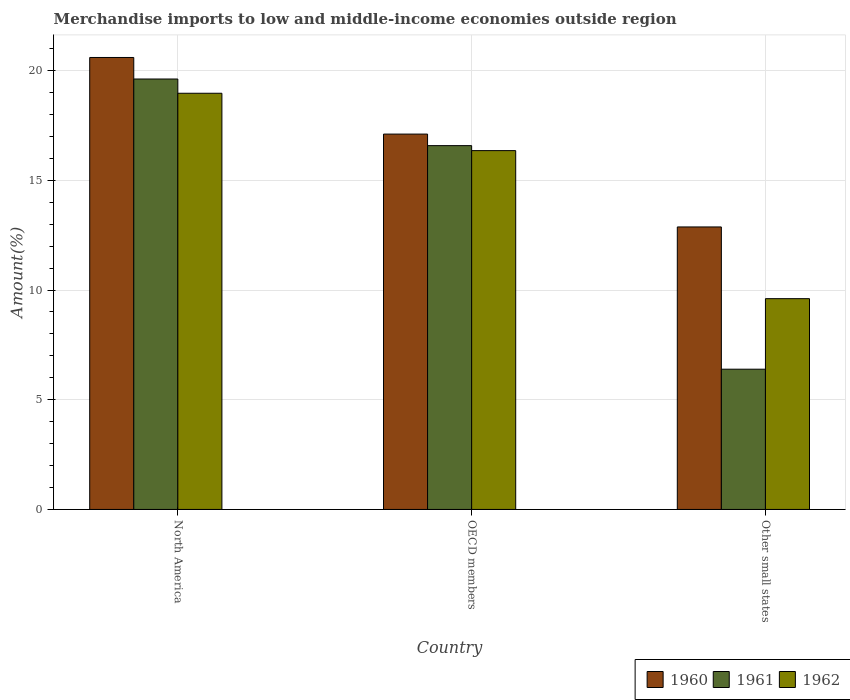How many different coloured bars are there?
Your answer should be compact. 3. How many groups of bars are there?
Your answer should be compact. 3. Are the number of bars on each tick of the X-axis equal?
Provide a short and direct response. Yes. How many bars are there on the 1st tick from the left?
Provide a short and direct response. 3. How many bars are there on the 3rd tick from the right?
Offer a terse response. 3. What is the label of the 1st group of bars from the left?
Provide a succinct answer. North America. What is the percentage of amount earned from merchandise imports in 1962 in OECD members?
Offer a terse response. 16.35. Across all countries, what is the maximum percentage of amount earned from merchandise imports in 1962?
Make the answer very short. 18.97. Across all countries, what is the minimum percentage of amount earned from merchandise imports in 1962?
Give a very brief answer. 9.61. In which country was the percentage of amount earned from merchandise imports in 1962 maximum?
Your answer should be very brief. North America. In which country was the percentage of amount earned from merchandise imports in 1962 minimum?
Offer a very short reply. Other small states. What is the total percentage of amount earned from merchandise imports in 1960 in the graph?
Provide a short and direct response. 50.58. What is the difference between the percentage of amount earned from merchandise imports in 1960 in North America and that in Other small states?
Offer a very short reply. 7.72. What is the difference between the percentage of amount earned from merchandise imports in 1961 in North America and the percentage of amount earned from merchandise imports in 1962 in Other small states?
Offer a very short reply. 10.01. What is the average percentage of amount earned from merchandise imports in 1962 per country?
Your response must be concise. 14.97. What is the difference between the percentage of amount earned from merchandise imports of/in 1960 and percentage of amount earned from merchandise imports of/in 1961 in North America?
Provide a short and direct response. 0.98. In how many countries, is the percentage of amount earned from merchandise imports in 1960 greater than 2 %?
Give a very brief answer. 3. What is the ratio of the percentage of amount earned from merchandise imports in 1962 in North America to that in Other small states?
Offer a very short reply. 1.97. What is the difference between the highest and the second highest percentage of amount earned from merchandise imports in 1960?
Offer a very short reply. -3.49. What is the difference between the highest and the lowest percentage of amount earned from merchandise imports in 1961?
Provide a succinct answer. 13.22. In how many countries, is the percentage of amount earned from merchandise imports in 1960 greater than the average percentage of amount earned from merchandise imports in 1960 taken over all countries?
Offer a very short reply. 2. Is the sum of the percentage of amount earned from merchandise imports in 1961 in OECD members and Other small states greater than the maximum percentage of amount earned from merchandise imports in 1962 across all countries?
Your answer should be compact. Yes. What does the 2nd bar from the right in North America represents?
Your response must be concise. 1961. How many bars are there?
Provide a succinct answer. 9. Are all the bars in the graph horizontal?
Offer a terse response. No. What is the difference between two consecutive major ticks on the Y-axis?
Your answer should be very brief. 5. Are the values on the major ticks of Y-axis written in scientific E-notation?
Offer a very short reply. No. Where does the legend appear in the graph?
Keep it short and to the point. Bottom right. What is the title of the graph?
Your answer should be very brief. Merchandise imports to low and middle-income economies outside region. Does "1963" appear as one of the legend labels in the graph?
Make the answer very short. No. What is the label or title of the X-axis?
Your answer should be compact. Country. What is the label or title of the Y-axis?
Make the answer very short. Amount(%). What is the Amount(%) in 1960 in North America?
Provide a short and direct response. 20.6. What is the Amount(%) of 1961 in North America?
Provide a short and direct response. 19.62. What is the Amount(%) in 1962 in North America?
Keep it short and to the point. 18.97. What is the Amount(%) of 1960 in OECD members?
Give a very brief answer. 17.11. What is the Amount(%) of 1961 in OECD members?
Provide a succinct answer. 16.58. What is the Amount(%) of 1962 in OECD members?
Offer a very short reply. 16.35. What is the Amount(%) in 1960 in Other small states?
Offer a very short reply. 12.87. What is the Amount(%) in 1961 in Other small states?
Offer a very short reply. 6.39. What is the Amount(%) of 1962 in Other small states?
Keep it short and to the point. 9.61. Across all countries, what is the maximum Amount(%) in 1960?
Keep it short and to the point. 20.6. Across all countries, what is the maximum Amount(%) in 1961?
Provide a succinct answer. 19.62. Across all countries, what is the maximum Amount(%) of 1962?
Provide a succinct answer. 18.97. Across all countries, what is the minimum Amount(%) in 1960?
Ensure brevity in your answer.  12.87. Across all countries, what is the minimum Amount(%) of 1961?
Offer a terse response. 6.39. Across all countries, what is the minimum Amount(%) in 1962?
Provide a succinct answer. 9.61. What is the total Amount(%) of 1960 in the graph?
Provide a short and direct response. 50.58. What is the total Amount(%) in 1961 in the graph?
Your answer should be compact. 42.59. What is the total Amount(%) of 1962 in the graph?
Keep it short and to the point. 44.92. What is the difference between the Amount(%) of 1960 in North America and that in OECD members?
Make the answer very short. 3.49. What is the difference between the Amount(%) of 1961 in North America and that in OECD members?
Ensure brevity in your answer.  3.04. What is the difference between the Amount(%) of 1962 in North America and that in OECD members?
Provide a succinct answer. 2.61. What is the difference between the Amount(%) in 1960 in North America and that in Other small states?
Provide a short and direct response. 7.72. What is the difference between the Amount(%) in 1961 in North America and that in Other small states?
Make the answer very short. 13.22. What is the difference between the Amount(%) in 1962 in North America and that in Other small states?
Ensure brevity in your answer.  9.36. What is the difference between the Amount(%) of 1960 in OECD members and that in Other small states?
Offer a terse response. 4.23. What is the difference between the Amount(%) in 1961 in OECD members and that in Other small states?
Your response must be concise. 10.19. What is the difference between the Amount(%) in 1962 in OECD members and that in Other small states?
Keep it short and to the point. 6.75. What is the difference between the Amount(%) in 1960 in North America and the Amount(%) in 1961 in OECD members?
Provide a short and direct response. 4.02. What is the difference between the Amount(%) of 1960 in North America and the Amount(%) of 1962 in OECD members?
Make the answer very short. 4.24. What is the difference between the Amount(%) of 1961 in North America and the Amount(%) of 1962 in OECD members?
Your answer should be very brief. 3.26. What is the difference between the Amount(%) of 1960 in North America and the Amount(%) of 1961 in Other small states?
Your answer should be compact. 14.21. What is the difference between the Amount(%) of 1960 in North America and the Amount(%) of 1962 in Other small states?
Make the answer very short. 10.99. What is the difference between the Amount(%) in 1961 in North America and the Amount(%) in 1962 in Other small states?
Give a very brief answer. 10.01. What is the difference between the Amount(%) of 1960 in OECD members and the Amount(%) of 1961 in Other small states?
Your answer should be very brief. 10.71. What is the difference between the Amount(%) of 1960 in OECD members and the Amount(%) of 1962 in Other small states?
Provide a succinct answer. 7.5. What is the difference between the Amount(%) of 1961 in OECD members and the Amount(%) of 1962 in Other small states?
Provide a succinct answer. 6.97. What is the average Amount(%) in 1960 per country?
Keep it short and to the point. 16.86. What is the average Amount(%) in 1961 per country?
Provide a succinct answer. 14.2. What is the average Amount(%) in 1962 per country?
Ensure brevity in your answer.  14.97. What is the difference between the Amount(%) in 1960 and Amount(%) in 1961 in North America?
Your response must be concise. 0.98. What is the difference between the Amount(%) of 1960 and Amount(%) of 1962 in North America?
Make the answer very short. 1.63. What is the difference between the Amount(%) of 1961 and Amount(%) of 1962 in North America?
Your response must be concise. 0.65. What is the difference between the Amount(%) in 1960 and Amount(%) in 1961 in OECD members?
Make the answer very short. 0.53. What is the difference between the Amount(%) of 1960 and Amount(%) of 1962 in OECD members?
Offer a terse response. 0.75. What is the difference between the Amount(%) of 1961 and Amount(%) of 1962 in OECD members?
Your response must be concise. 0.23. What is the difference between the Amount(%) of 1960 and Amount(%) of 1961 in Other small states?
Offer a terse response. 6.48. What is the difference between the Amount(%) in 1960 and Amount(%) in 1962 in Other small states?
Provide a succinct answer. 3.27. What is the difference between the Amount(%) in 1961 and Amount(%) in 1962 in Other small states?
Your answer should be compact. -3.21. What is the ratio of the Amount(%) of 1960 in North America to that in OECD members?
Provide a short and direct response. 1.2. What is the ratio of the Amount(%) in 1961 in North America to that in OECD members?
Keep it short and to the point. 1.18. What is the ratio of the Amount(%) in 1962 in North America to that in OECD members?
Provide a short and direct response. 1.16. What is the ratio of the Amount(%) of 1960 in North America to that in Other small states?
Make the answer very short. 1.6. What is the ratio of the Amount(%) in 1961 in North America to that in Other small states?
Offer a terse response. 3.07. What is the ratio of the Amount(%) in 1962 in North America to that in Other small states?
Offer a very short reply. 1.97. What is the ratio of the Amount(%) in 1960 in OECD members to that in Other small states?
Ensure brevity in your answer.  1.33. What is the ratio of the Amount(%) of 1961 in OECD members to that in Other small states?
Keep it short and to the point. 2.59. What is the ratio of the Amount(%) in 1962 in OECD members to that in Other small states?
Keep it short and to the point. 1.7. What is the difference between the highest and the second highest Amount(%) of 1960?
Offer a terse response. 3.49. What is the difference between the highest and the second highest Amount(%) in 1961?
Keep it short and to the point. 3.04. What is the difference between the highest and the second highest Amount(%) of 1962?
Give a very brief answer. 2.61. What is the difference between the highest and the lowest Amount(%) of 1960?
Provide a short and direct response. 7.72. What is the difference between the highest and the lowest Amount(%) in 1961?
Your answer should be compact. 13.22. What is the difference between the highest and the lowest Amount(%) of 1962?
Ensure brevity in your answer.  9.36. 